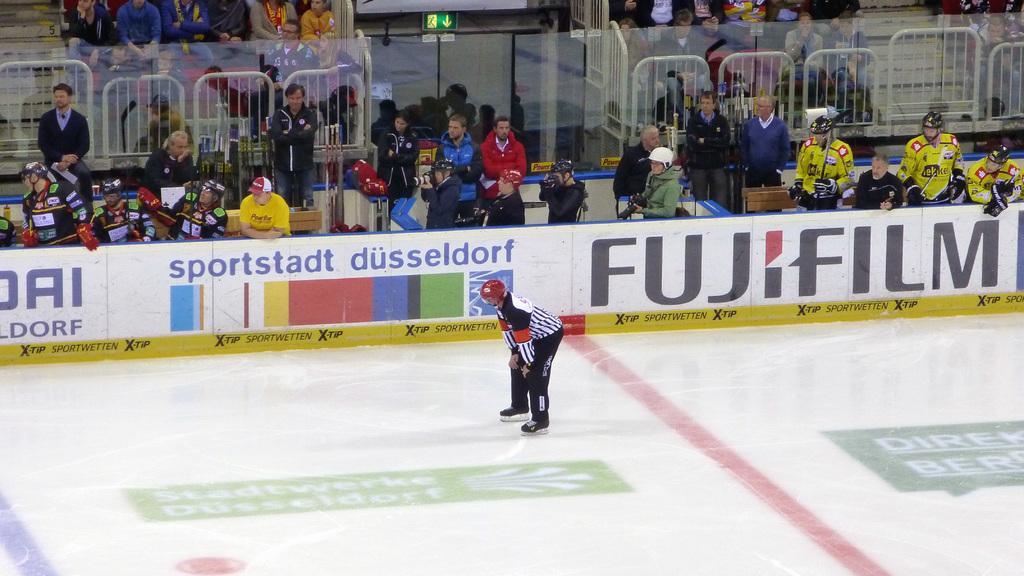Can you describe this image briefly? At the bottom of the image there is ice. In the middle of the image a man is doing skating on ice. Behind him there is fencing. Behind the fencing few people are standing and sitting and holding something in their hands and there is a sign board. 